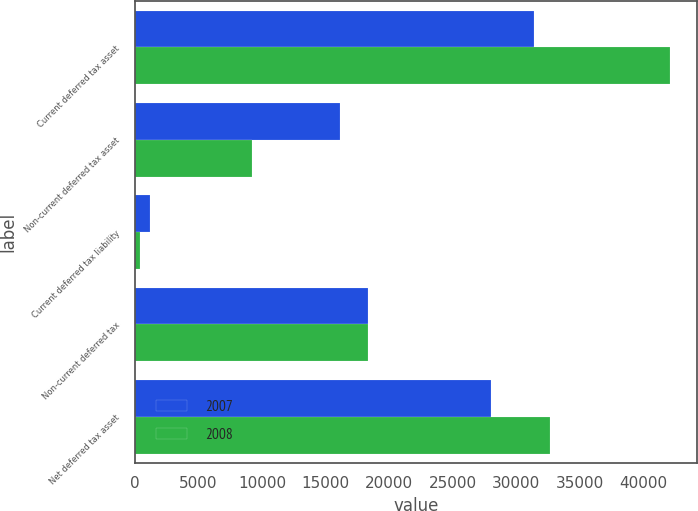Convert chart. <chart><loc_0><loc_0><loc_500><loc_500><stacked_bar_chart><ecel><fcel>Current deferred tax asset<fcel>Non-current deferred tax asset<fcel>Current deferred tax liability<fcel>Non-current deferred tax<fcel>Net deferred tax asset<nl><fcel>2007<fcel>31355<fcel>16162<fcel>1150<fcel>18333<fcel>28034<nl><fcel>2008<fcel>42109<fcel>9206<fcel>415<fcel>18297<fcel>32603<nl></chart> 